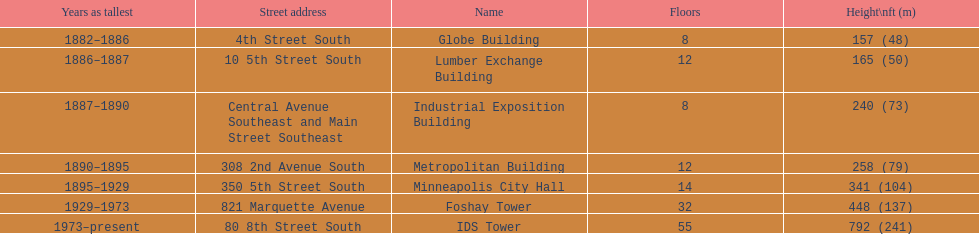How many buildings on the list are taller than 200 feet? 5. 